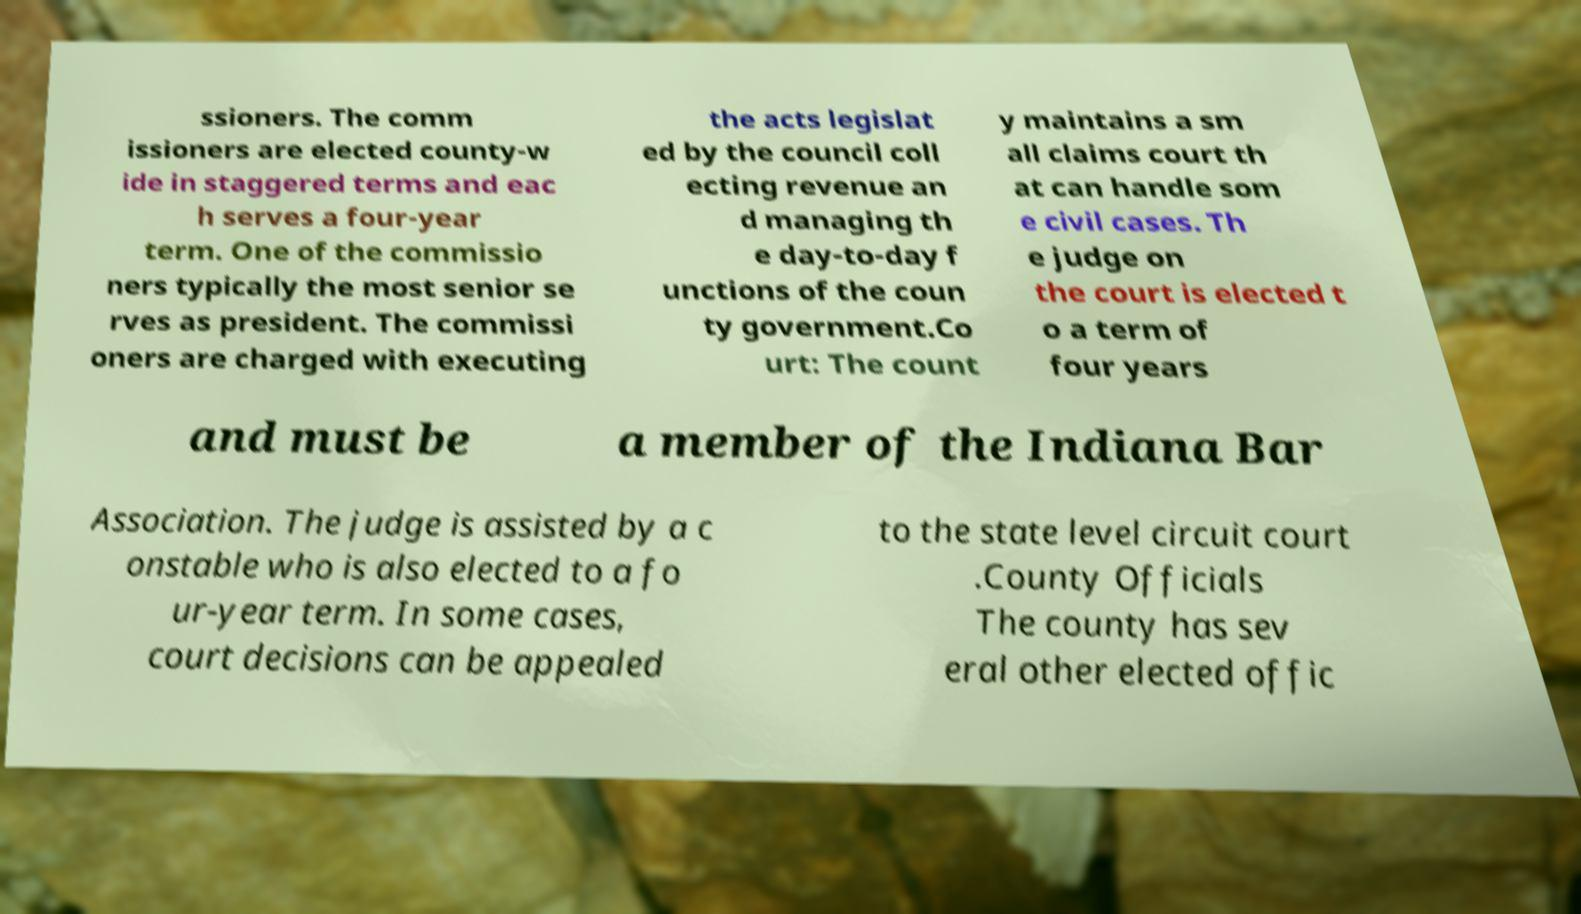Please identify and transcribe the text found in this image. ssioners. The comm issioners are elected county-w ide in staggered terms and eac h serves a four-year term. One of the commissio ners typically the most senior se rves as president. The commissi oners are charged with executing the acts legislat ed by the council coll ecting revenue an d managing th e day-to-day f unctions of the coun ty government.Co urt: The count y maintains a sm all claims court th at can handle som e civil cases. Th e judge on the court is elected t o a term of four years and must be a member of the Indiana Bar Association. The judge is assisted by a c onstable who is also elected to a fo ur-year term. In some cases, court decisions can be appealed to the state level circuit court .County Officials The county has sev eral other elected offic 